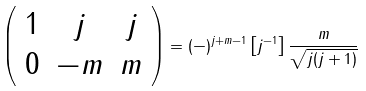Convert formula to latex. <formula><loc_0><loc_0><loc_500><loc_500>\left ( \begin{array} { c c c } 1 & j & j \\ 0 & - m & m \end{array} \right ) = ( - ) ^ { j + m - 1 } \left [ j ^ { - 1 } \right ] \frac { m } { \sqrt { j ( j + 1 ) } }</formula> 